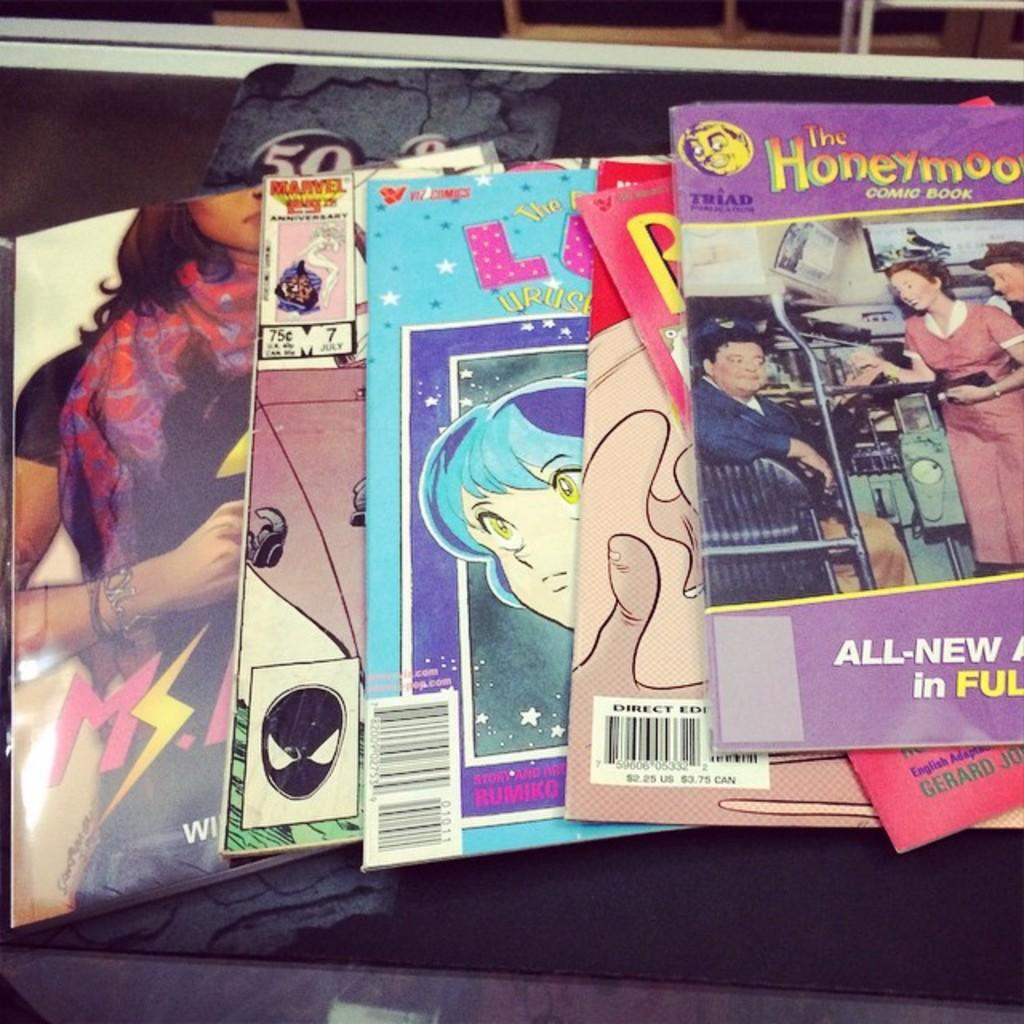<image>
Render a clear and concise summary of the photo. Many vintage comic books are on display, including The Honeymooners. 